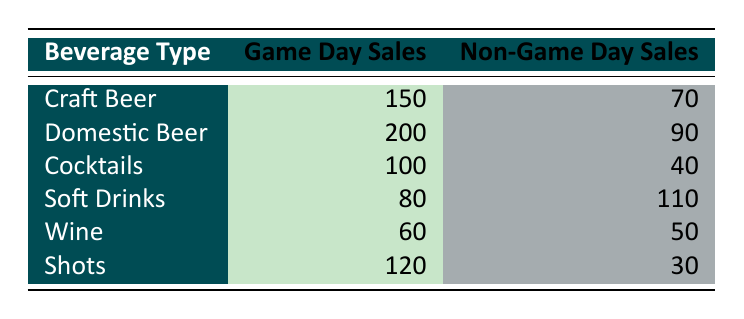What is the sales figure for Domestic Beer on game days? The table lists Domestic Beer under the "Beverage Type" column. When checking the "Game Day Sales" column next to it, the value is 200.
Answer: 200 How much is the sales figure for Soft Drinks on non-game days? Referring to the table, under the "Beverage Type" column, Soft Drinks is listed, and its corresponding value in the "Non-Game Day Sales" column is 110.
Answer: 110 Which beverage has the highest sales on game days? By examining the "Game Day Sales" column, the highest value can be seen next to Domestic Beer, which is 200, making it the beverage with the highest sales on game days.
Answer: Domestic Beer What is the total sales amount for Cocktails on both game days and non-game days? The sales for Cocktails are 100 on game days and 40 on non-game days. To find the total, we sum these two figures: 100 + 40 = 140.
Answer: 140 Is the sales figure for Wine on game days greater than that on non-game days? The table shows Wine sales as 60 on game days and 50 on non-game days. Comparing these two figures, 60 is indeed greater than 50, confirming that Wine sales on game days are higher.
Answer: Yes What is the difference in sales between Craft Beer on game days and Domestic Beer on non-game days? Craft Beer on game days sells for 150, while Domestic Beer on non-game days sells for 90. To find the difference, we perform the subtraction: 150 - 90 = 60.
Answer: 60 Which beverage type has the lowest sales on game days? Looking at the "Game Day Sales" values, we find Wine with 60 as the lowest amount compared to other beverages listed.
Answer: Wine What is the average sales figure of Shots and Cocktails on game days? The sales figures for Shots and Cocktails on game days are 120 and 100, respectively. To compute the average, we sum these figures (120 + 100 = 220) and divide by 2 (220 / 2 = 110).
Answer: 110 Is it true that Soft Drinks sold more on non-game days than Cocktails sold on game days? Soft Drinks sales on non-game days are recorded as 110, while Cocktails sales on game days are recorded as 100. Since 110 is greater than 100, the statement is true.
Answer: Yes 